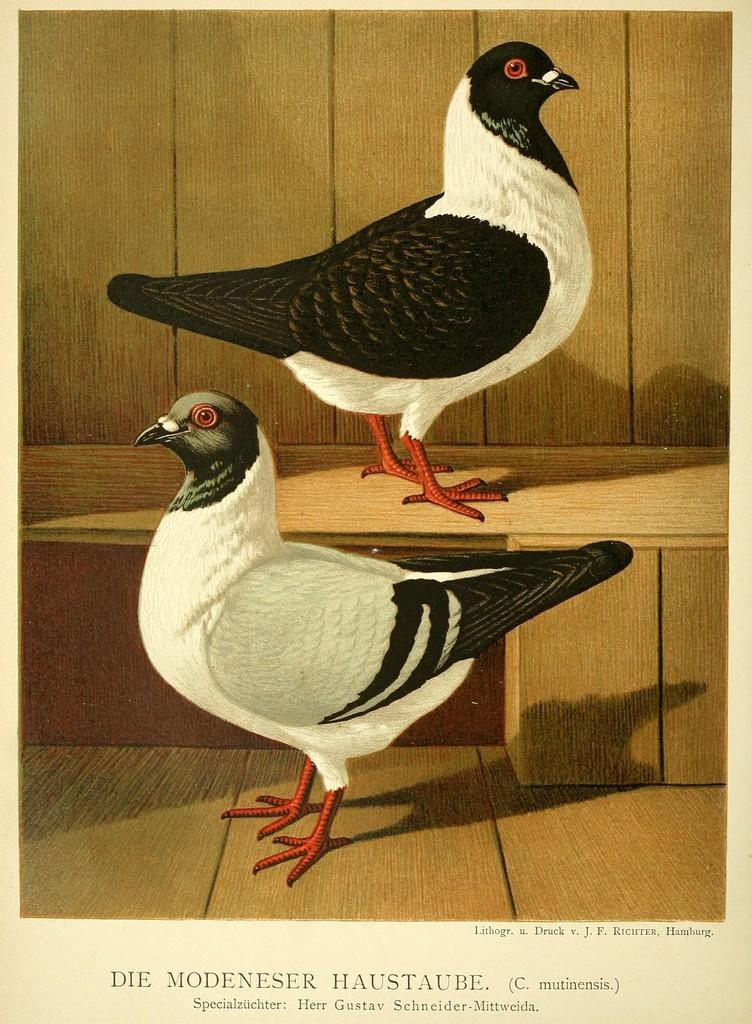What is the main subject of the image? There is an art piece in the image. What is depicted in the art piece? The art piece depicts two birds. What is the surface the birds are standing on? The birds are standing on a wooden floor. How are the birds positioned relative to each other? One bird is above the other. What additional information is provided at the bottom of the image? There is text at the bottom of the image. What type of chicken is being cooked by your dad in the image? There is no chicken or dad present in the image; it features an art piece depicting two birds on a wooden floor with text at the bottom. Can you see any steam coming from the art piece in the image? There is no steam present in the image; it is a static art piece featuring two birds on a wooden floor. 